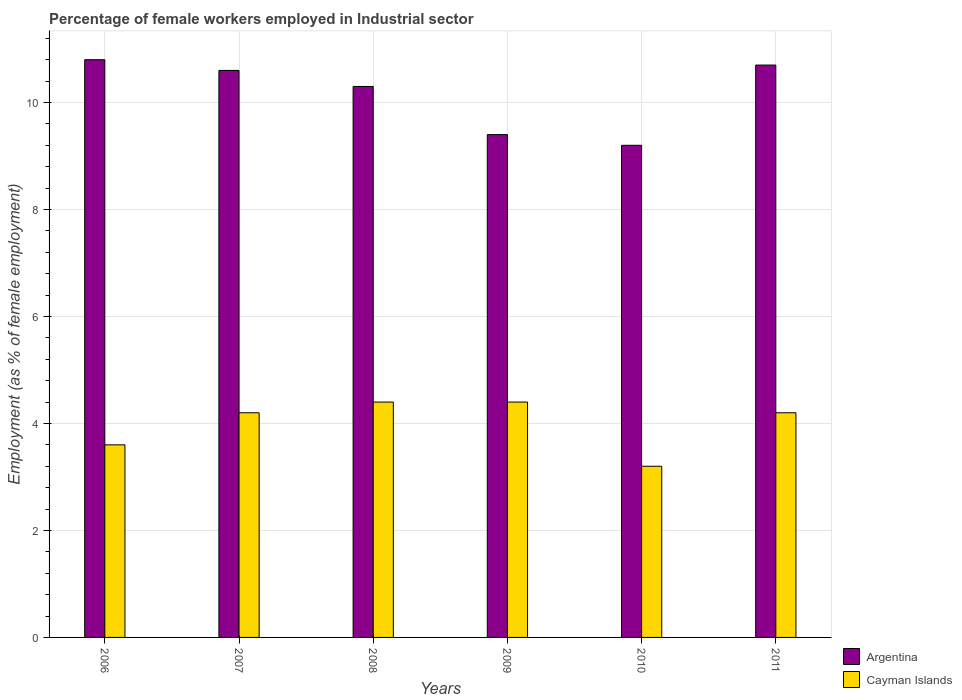How many groups of bars are there?
Provide a succinct answer. 6. Are the number of bars per tick equal to the number of legend labels?
Offer a terse response. Yes. Are the number of bars on each tick of the X-axis equal?
Make the answer very short. Yes. What is the label of the 3rd group of bars from the left?
Provide a succinct answer. 2008. In how many cases, is the number of bars for a given year not equal to the number of legend labels?
Keep it short and to the point. 0. What is the percentage of females employed in Industrial sector in Argentina in 2006?
Offer a very short reply. 10.8. Across all years, what is the maximum percentage of females employed in Industrial sector in Cayman Islands?
Offer a very short reply. 4.4. Across all years, what is the minimum percentage of females employed in Industrial sector in Argentina?
Your answer should be very brief. 9.2. In which year was the percentage of females employed in Industrial sector in Cayman Islands minimum?
Your response must be concise. 2010. What is the total percentage of females employed in Industrial sector in Argentina in the graph?
Offer a terse response. 61. What is the difference between the percentage of females employed in Industrial sector in Cayman Islands in 2006 and that in 2009?
Ensure brevity in your answer.  -0.8. What is the difference between the percentage of females employed in Industrial sector in Argentina in 2010 and the percentage of females employed in Industrial sector in Cayman Islands in 2009?
Offer a terse response. 4.8. What is the average percentage of females employed in Industrial sector in Cayman Islands per year?
Your answer should be compact. 4. In the year 2006, what is the difference between the percentage of females employed in Industrial sector in Cayman Islands and percentage of females employed in Industrial sector in Argentina?
Ensure brevity in your answer.  -7.2. In how many years, is the percentage of females employed in Industrial sector in Cayman Islands greater than 4.8 %?
Your response must be concise. 0. What is the ratio of the percentage of females employed in Industrial sector in Cayman Islands in 2010 to that in 2011?
Ensure brevity in your answer.  0.76. Is the percentage of females employed in Industrial sector in Cayman Islands in 2006 less than that in 2007?
Offer a terse response. Yes. What is the difference between the highest and the second highest percentage of females employed in Industrial sector in Argentina?
Give a very brief answer. 0.1. What is the difference between the highest and the lowest percentage of females employed in Industrial sector in Argentina?
Your answer should be compact. 1.6. In how many years, is the percentage of females employed in Industrial sector in Cayman Islands greater than the average percentage of females employed in Industrial sector in Cayman Islands taken over all years?
Ensure brevity in your answer.  4. Is the sum of the percentage of females employed in Industrial sector in Cayman Islands in 2007 and 2009 greater than the maximum percentage of females employed in Industrial sector in Argentina across all years?
Give a very brief answer. No. What does the 2nd bar from the left in 2009 represents?
Your answer should be compact. Cayman Islands. What does the 1st bar from the right in 2009 represents?
Provide a succinct answer. Cayman Islands. How many bars are there?
Make the answer very short. 12. Are all the bars in the graph horizontal?
Give a very brief answer. No. Does the graph contain any zero values?
Provide a succinct answer. No. Does the graph contain grids?
Keep it short and to the point. Yes. How many legend labels are there?
Offer a terse response. 2. How are the legend labels stacked?
Ensure brevity in your answer.  Vertical. What is the title of the graph?
Provide a succinct answer. Percentage of female workers employed in Industrial sector. What is the label or title of the Y-axis?
Ensure brevity in your answer.  Employment (as % of female employment). What is the Employment (as % of female employment) in Argentina in 2006?
Give a very brief answer. 10.8. What is the Employment (as % of female employment) in Cayman Islands in 2006?
Keep it short and to the point. 3.6. What is the Employment (as % of female employment) in Argentina in 2007?
Offer a terse response. 10.6. What is the Employment (as % of female employment) of Cayman Islands in 2007?
Give a very brief answer. 4.2. What is the Employment (as % of female employment) of Argentina in 2008?
Provide a succinct answer. 10.3. What is the Employment (as % of female employment) of Cayman Islands in 2008?
Offer a very short reply. 4.4. What is the Employment (as % of female employment) in Argentina in 2009?
Offer a very short reply. 9.4. What is the Employment (as % of female employment) of Cayman Islands in 2009?
Offer a very short reply. 4.4. What is the Employment (as % of female employment) of Argentina in 2010?
Your answer should be very brief. 9.2. What is the Employment (as % of female employment) in Cayman Islands in 2010?
Keep it short and to the point. 3.2. What is the Employment (as % of female employment) of Argentina in 2011?
Give a very brief answer. 10.7. What is the Employment (as % of female employment) of Cayman Islands in 2011?
Ensure brevity in your answer.  4.2. Across all years, what is the maximum Employment (as % of female employment) of Argentina?
Provide a short and direct response. 10.8. Across all years, what is the maximum Employment (as % of female employment) in Cayman Islands?
Your answer should be very brief. 4.4. Across all years, what is the minimum Employment (as % of female employment) in Argentina?
Your response must be concise. 9.2. Across all years, what is the minimum Employment (as % of female employment) of Cayman Islands?
Offer a very short reply. 3.2. What is the total Employment (as % of female employment) in Argentina in the graph?
Provide a short and direct response. 61. What is the total Employment (as % of female employment) of Cayman Islands in the graph?
Provide a short and direct response. 24. What is the difference between the Employment (as % of female employment) in Argentina in 2006 and that in 2009?
Your response must be concise. 1.4. What is the difference between the Employment (as % of female employment) of Argentina in 2006 and that in 2010?
Keep it short and to the point. 1.6. What is the difference between the Employment (as % of female employment) in Cayman Islands in 2006 and that in 2010?
Keep it short and to the point. 0.4. What is the difference between the Employment (as % of female employment) in Argentina in 2006 and that in 2011?
Give a very brief answer. 0.1. What is the difference between the Employment (as % of female employment) in Cayman Islands in 2006 and that in 2011?
Your answer should be very brief. -0.6. What is the difference between the Employment (as % of female employment) of Argentina in 2007 and that in 2008?
Offer a terse response. 0.3. What is the difference between the Employment (as % of female employment) of Cayman Islands in 2007 and that in 2008?
Your answer should be very brief. -0.2. What is the difference between the Employment (as % of female employment) in Argentina in 2007 and that in 2009?
Keep it short and to the point. 1.2. What is the difference between the Employment (as % of female employment) of Cayman Islands in 2007 and that in 2009?
Offer a terse response. -0.2. What is the difference between the Employment (as % of female employment) of Argentina in 2007 and that in 2011?
Provide a short and direct response. -0.1. What is the difference between the Employment (as % of female employment) of Argentina in 2008 and that in 2009?
Your answer should be compact. 0.9. What is the difference between the Employment (as % of female employment) of Cayman Islands in 2008 and that in 2009?
Offer a very short reply. 0. What is the difference between the Employment (as % of female employment) of Argentina in 2008 and that in 2010?
Give a very brief answer. 1.1. What is the difference between the Employment (as % of female employment) in Cayman Islands in 2008 and that in 2010?
Offer a terse response. 1.2. What is the difference between the Employment (as % of female employment) in Cayman Islands in 2008 and that in 2011?
Your answer should be compact. 0.2. What is the difference between the Employment (as % of female employment) of Argentina in 2009 and that in 2011?
Your response must be concise. -1.3. What is the difference between the Employment (as % of female employment) in Cayman Islands in 2009 and that in 2011?
Ensure brevity in your answer.  0.2. What is the difference between the Employment (as % of female employment) in Argentina in 2010 and that in 2011?
Offer a very short reply. -1.5. What is the difference between the Employment (as % of female employment) in Cayman Islands in 2010 and that in 2011?
Make the answer very short. -1. What is the difference between the Employment (as % of female employment) of Argentina in 2006 and the Employment (as % of female employment) of Cayman Islands in 2008?
Provide a succinct answer. 6.4. What is the difference between the Employment (as % of female employment) in Argentina in 2006 and the Employment (as % of female employment) in Cayman Islands in 2009?
Make the answer very short. 6.4. What is the difference between the Employment (as % of female employment) in Argentina in 2007 and the Employment (as % of female employment) in Cayman Islands in 2009?
Keep it short and to the point. 6.2. What is the difference between the Employment (as % of female employment) in Argentina in 2007 and the Employment (as % of female employment) in Cayman Islands in 2010?
Provide a succinct answer. 7.4. What is the difference between the Employment (as % of female employment) of Argentina in 2008 and the Employment (as % of female employment) of Cayman Islands in 2009?
Offer a terse response. 5.9. What is the difference between the Employment (as % of female employment) in Argentina in 2008 and the Employment (as % of female employment) in Cayman Islands in 2010?
Ensure brevity in your answer.  7.1. What is the difference between the Employment (as % of female employment) of Argentina in 2008 and the Employment (as % of female employment) of Cayman Islands in 2011?
Ensure brevity in your answer.  6.1. What is the average Employment (as % of female employment) in Argentina per year?
Offer a very short reply. 10.17. What is the average Employment (as % of female employment) in Cayman Islands per year?
Ensure brevity in your answer.  4. In the year 2007, what is the difference between the Employment (as % of female employment) in Argentina and Employment (as % of female employment) in Cayman Islands?
Your answer should be very brief. 6.4. In the year 2008, what is the difference between the Employment (as % of female employment) of Argentina and Employment (as % of female employment) of Cayman Islands?
Make the answer very short. 5.9. In the year 2010, what is the difference between the Employment (as % of female employment) of Argentina and Employment (as % of female employment) of Cayman Islands?
Your answer should be compact. 6. What is the ratio of the Employment (as % of female employment) of Argentina in 2006 to that in 2007?
Offer a terse response. 1.02. What is the ratio of the Employment (as % of female employment) of Argentina in 2006 to that in 2008?
Your answer should be compact. 1.05. What is the ratio of the Employment (as % of female employment) of Cayman Islands in 2006 to that in 2008?
Give a very brief answer. 0.82. What is the ratio of the Employment (as % of female employment) in Argentina in 2006 to that in 2009?
Your answer should be very brief. 1.15. What is the ratio of the Employment (as % of female employment) in Cayman Islands in 2006 to that in 2009?
Make the answer very short. 0.82. What is the ratio of the Employment (as % of female employment) in Argentina in 2006 to that in 2010?
Offer a very short reply. 1.17. What is the ratio of the Employment (as % of female employment) of Argentina in 2006 to that in 2011?
Ensure brevity in your answer.  1.01. What is the ratio of the Employment (as % of female employment) in Argentina in 2007 to that in 2008?
Your answer should be compact. 1.03. What is the ratio of the Employment (as % of female employment) in Cayman Islands in 2007 to that in 2008?
Provide a succinct answer. 0.95. What is the ratio of the Employment (as % of female employment) of Argentina in 2007 to that in 2009?
Your answer should be compact. 1.13. What is the ratio of the Employment (as % of female employment) of Cayman Islands in 2007 to that in 2009?
Your answer should be compact. 0.95. What is the ratio of the Employment (as % of female employment) in Argentina in 2007 to that in 2010?
Provide a short and direct response. 1.15. What is the ratio of the Employment (as % of female employment) in Cayman Islands in 2007 to that in 2010?
Offer a very short reply. 1.31. What is the ratio of the Employment (as % of female employment) of Argentina in 2007 to that in 2011?
Offer a terse response. 0.99. What is the ratio of the Employment (as % of female employment) of Cayman Islands in 2007 to that in 2011?
Your answer should be compact. 1. What is the ratio of the Employment (as % of female employment) in Argentina in 2008 to that in 2009?
Offer a terse response. 1.1. What is the ratio of the Employment (as % of female employment) in Cayman Islands in 2008 to that in 2009?
Provide a succinct answer. 1. What is the ratio of the Employment (as % of female employment) of Argentina in 2008 to that in 2010?
Your answer should be very brief. 1.12. What is the ratio of the Employment (as % of female employment) in Cayman Islands in 2008 to that in 2010?
Provide a short and direct response. 1.38. What is the ratio of the Employment (as % of female employment) of Argentina in 2008 to that in 2011?
Ensure brevity in your answer.  0.96. What is the ratio of the Employment (as % of female employment) of Cayman Islands in 2008 to that in 2011?
Make the answer very short. 1.05. What is the ratio of the Employment (as % of female employment) of Argentina in 2009 to that in 2010?
Offer a very short reply. 1.02. What is the ratio of the Employment (as % of female employment) of Cayman Islands in 2009 to that in 2010?
Give a very brief answer. 1.38. What is the ratio of the Employment (as % of female employment) of Argentina in 2009 to that in 2011?
Offer a terse response. 0.88. What is the ratio of the Employment (as % of female employment) in Cayman Islands in 2009 to that in 2011?
Ensure brevity in your answer.  1.05. What is the ratio of the Employment (as % of female employment) in Argentina in 2010 to that in 2011?
Provide a succinct answer. 0.86. What is the ratio of the Employment (as % of female employment) in Cayman Islands in 2010 to that in 2011?
Offer a terse response. 0.76. What is the difference between the highest and the second highest Employment (as % of female employment) in Argentina?
Offer a very short reply. 0.1. What is the difference between the highest and the lowest Employment (as % of female employment) of Argentina?
Offer a very short reply. 1.6. What is the difference between the highest and the lowest Employment (as % of female employment) of Cayman Islands?
Give a very brief answer. 1.2. 